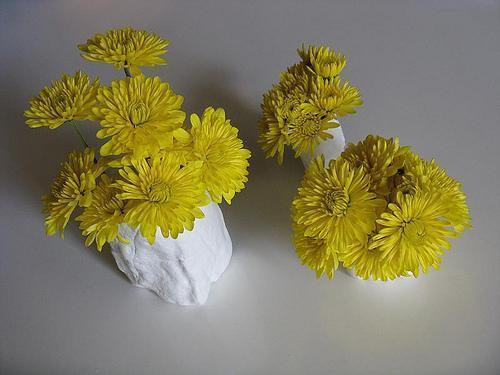How many groups of flowers are there?
Give a very brief answer. 3. How many flowers are in the group on the left?
Give a very brief answer. 7. 